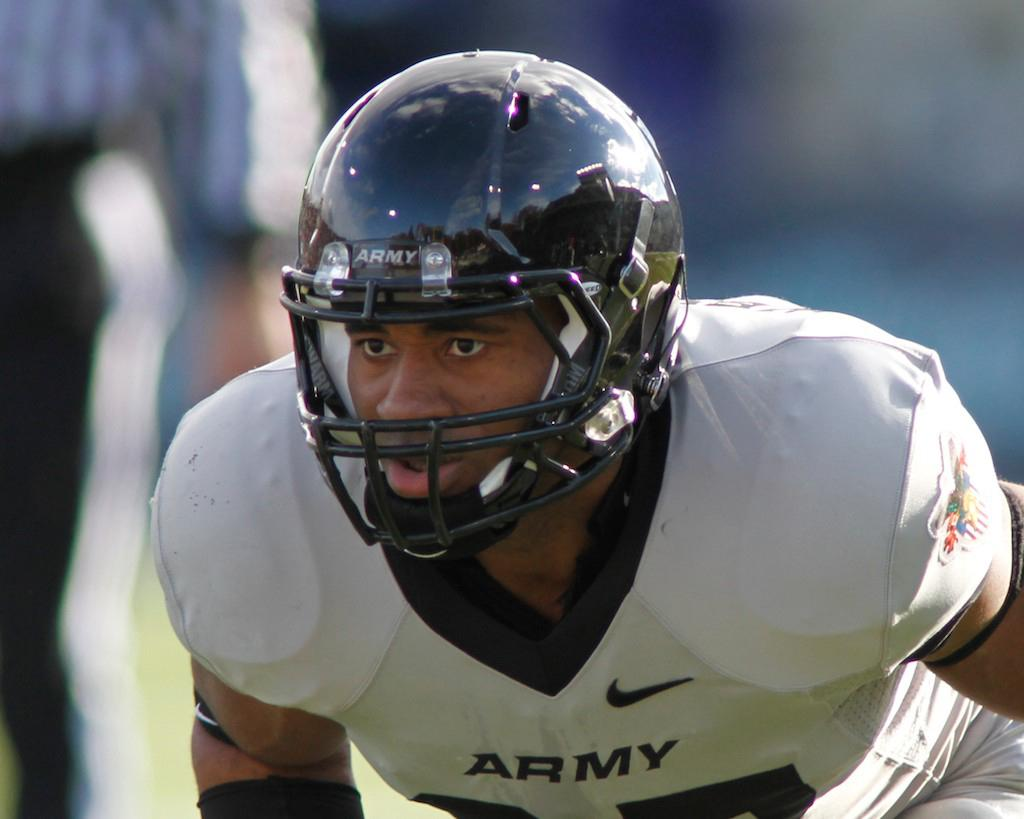Who is present in the image? There is a man in the image. What is the man wearing on his head? The man is wearing a helmet. What color are the clothes the man is wearing? The man is wearing white color clothes. Can you describe the background of the image? The background of the image is blurred. How many pages are visible in the image? There are no pages present in the image. What type of bubble can be seen in the image? There are no bubbles present in the image. 